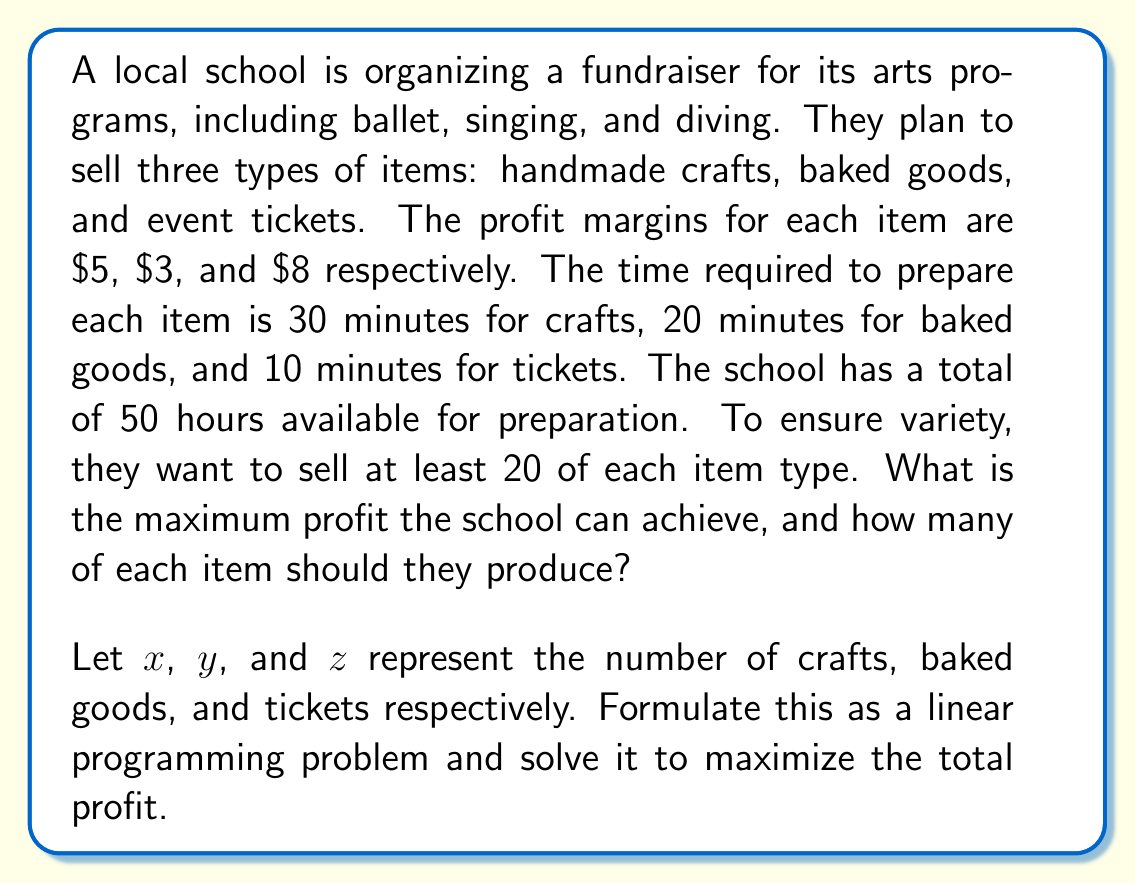Show me your answer to this math problem. To solve this problem, we need to set up a linear programming model and then solve it. Let's break it down step-by-step:

1. Define the objective function:
   Maximize profit: $P = 5x + 3y + 8z$

2. Set up the constraints:
   a) Time constraint: $0.5x + \frac{1}{3}y + \frac{1}{6}z \leq 50$ (converting 50 hours to minutes)
   b) Minimum quantity constraints: $x \geq 20$, $y \geq 20$, $z \geq 20$
   c) Non-negativity constraints: $x, y, z \geq 0$

3. The complete linear programming model:

   Maximize $P = 5x + 3y + 8z$
   Subject to:
   $$\begin{align}
   0.5x + \frac{1}{3}y + \frac{1}{6}z &\leq 50 \\
   x &\geq 20 \\
   y &\geq 20 \\
   z &\geq 20 \\
   x, y, z &\geq 0
   \end{align}$$

4. To solve this, we can use the simplex method or a linear programming solver. However, we can also reason through it:

   a) First, we must satisfy the minimum quantity constraints: 20 of each item.
   b) This uses up $(20 \cdot 0.5) + (20 \cdot \frac{1}{3}) + (20 \cdot \frac{1}{6}) = 20$ hours.
   c) We have 30 hours left to allocate.
   d) The most profitable item per time unit is tickets ($8 per 10 minutes, or $48 per hour).
   e) We should use the remaining time to produce as many tickets as possible.
   f) In 30 hours, we can produce an additional $30 \cdot 6 = 180$ tickets.

5. Therefore, the optimal solution is:
   $x = 20$ (crafts)
   $y = 20$ (baked goods)
   $z = 20 + 180 = 200$ (tickets)

6. The maximum profit is:
   $P = 5(20) + 3(20) + 8(200) = 100 + 60 + 1600 = 1760$
Answer: The school should produce 20 crafts, 20 baked goods, and 200 tickets to maximize their profit, which will be $1760. 